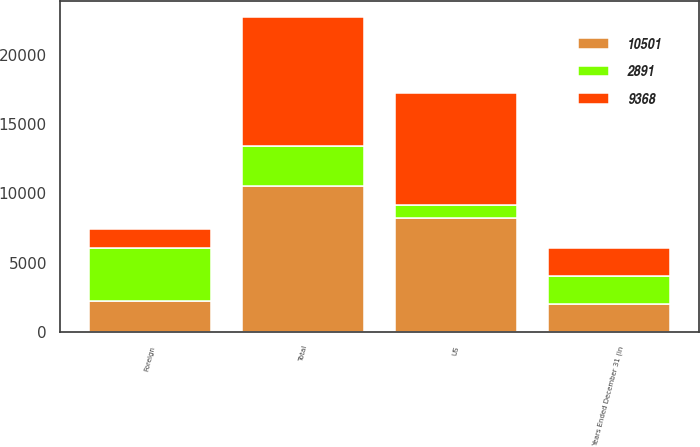Convert chart. <chart><loc_0><loc_0><loc_500><loc_500><stacked_bar_chart><ecel><fcel>Years Ended December 31 (in<fcel>US<fcel>Foreign<fcel>Total<nl><fcel>10501<fcel>2014<fcel>8250<fcel>2251<fcel>10501<nl><fcel>9368<fcel>2013<fcel>8058<fcel>1310<fcel>9368<nl><fcel>2891<fcel>2012<fcel>948<fcel>3839<fcel>2891<nl></chart> 